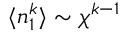Convert formula to latex. <formula><loc_0><loc_0><loc_500><loc_500>\langle n _ { 1 } ^ { k } \rangle \sim \chi ^ { k - 1 }</formula> 